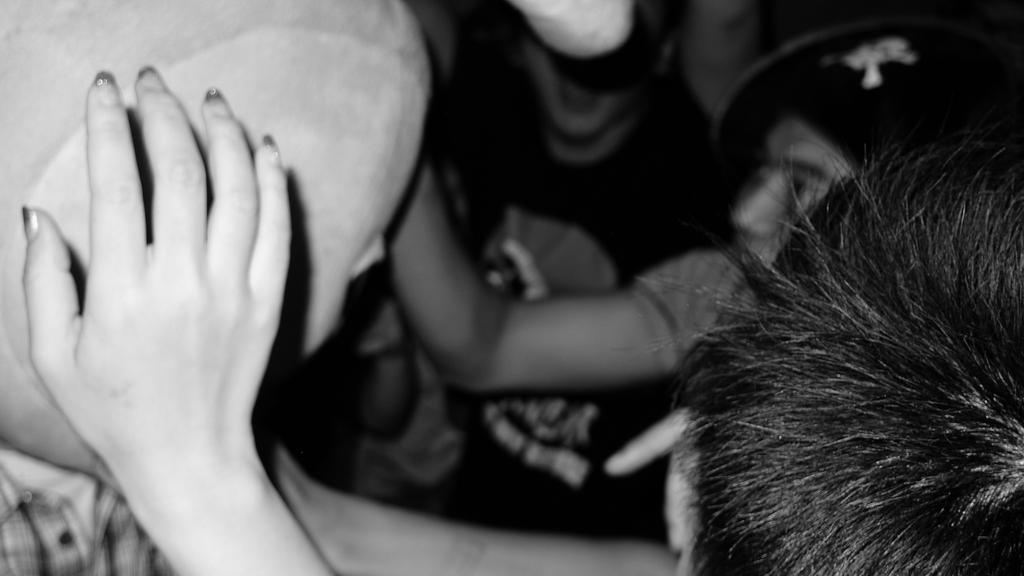What is the color scheme of the image? The image is black and white. Can you describe the subjects in the image? There are people in the image. Where is a person's hand located in the image? A person's hand is visible on the left side of the image. How many crows can be seen flying in the image? There are no crows present in the image; it is a black and white image featuring people. What type of ground is visible in the image? There is no ground visible in the image, as it is a black and white image featuring people. 